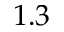<formula> <loc_0><loc_0><loc_500><loc_500>1 . 3</formula> 